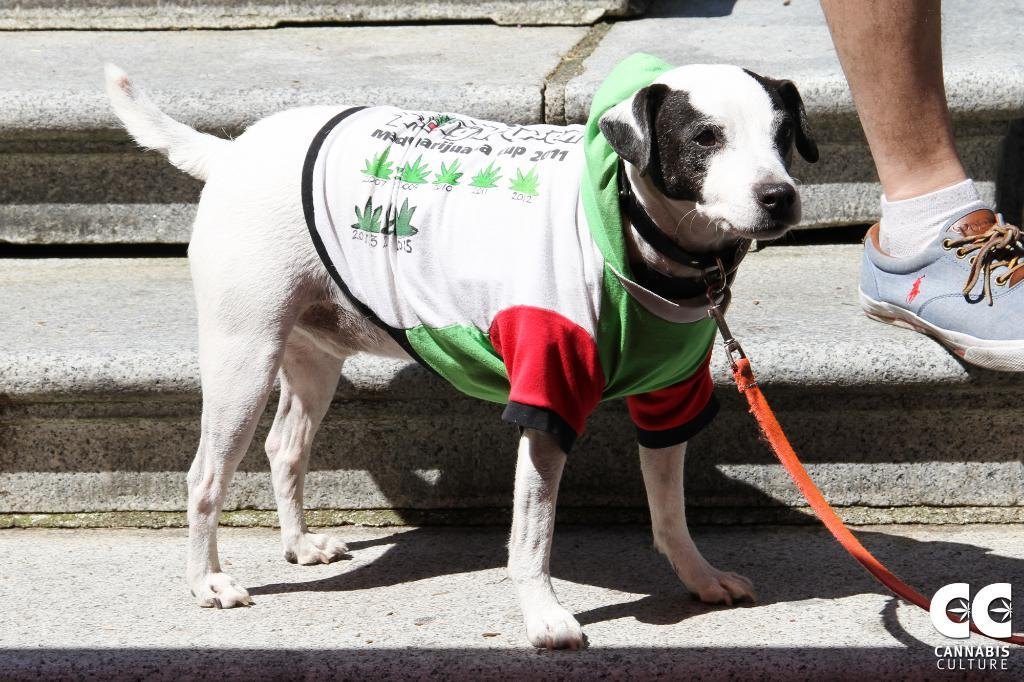What animal is present in the image? There is a dog in the image. Where is the dog located in the image? The dog is standing on the stairs. Can you see any part of a person in the image? Yes, there is a leg of a person visible in the image. What theory is the dog trying to prove in the image? There is no theory present in the image; it simply shows a dog standing on the stairs. Can you see a basket in the image? No, there is no basket present in the image. 